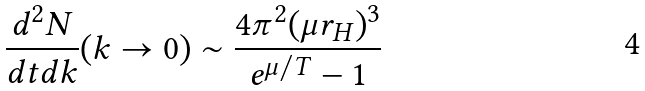Convert formula to latex. <formula><loc_0><loc_0><loc_500><loc_500>\frac { d ^ { 2 } N } { d t d k } ( k \to 0 ) \sim \frac { 4 \pi ^ { 2 } ( \mu { r } _ { H } ) ^ { 3 } } { e ^ { \mu / T } - 1 }</formula> 